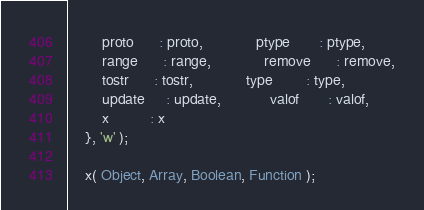<code> <loc_0><loc_0><loc_500><loc_500><_JavaScript_>		proto      : proto,             ptype       : ptype,
		range      : range,             remove      : remove,
		tostr      : tostr,             type        : type,
		update     : update,            valof       : valof,
		x          : x
	}, 'w' );

	x( Object, Array, Boolean, Function );
</code> 